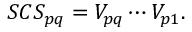<formula> <loc_0><loc_0><loc_500><loc_500>S C S _ { p q } = V _ { p q } \cdots V _ { p 1 } .</formula> 